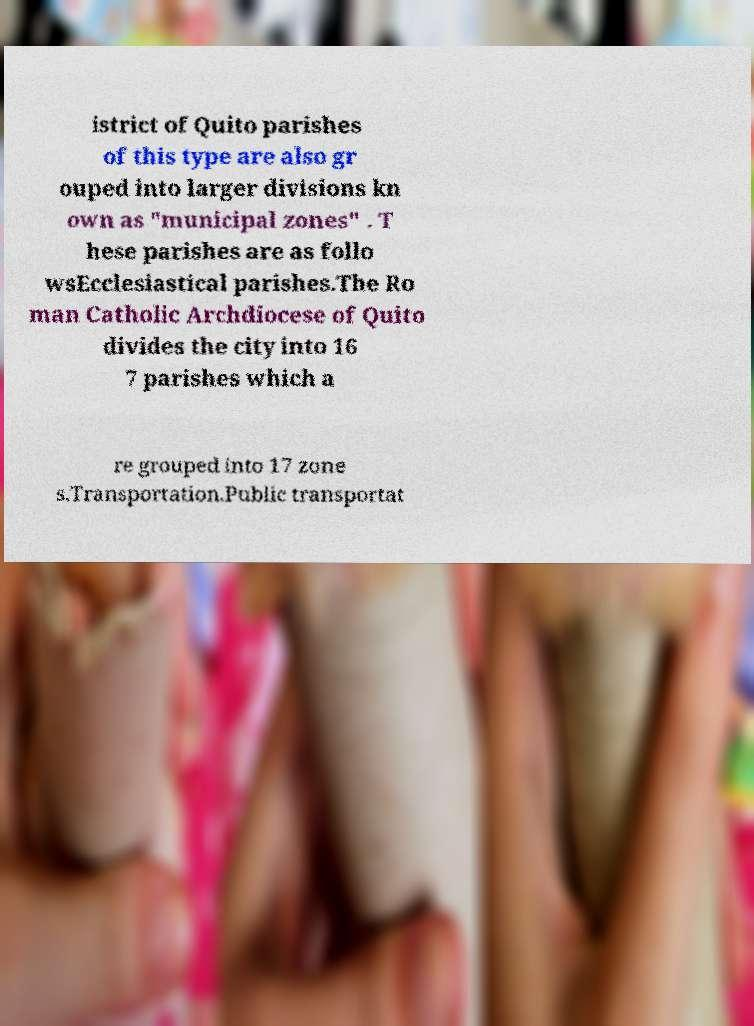I need the written content from this picture converted into text. Can you do that? istrict of Quito parishes of this type are also gr ouped into larger divisions kn own as "municipal zones" . T hese parishes are as follo wsEcclesiastical parishes.The Ro man Catholic Archdiocese of Quito divides the city into 16 7 parishes which a re grouped into 17 zone s.Transportation.Public transportat 